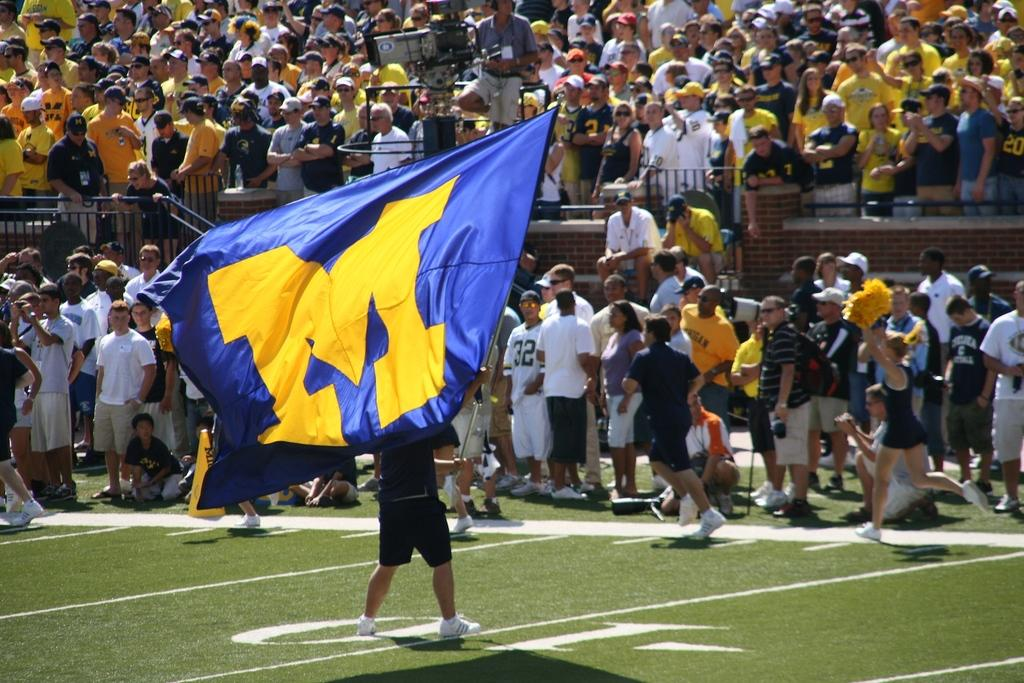Provide a one-sentence caption for the provided image. a person holding a M flag that is gold and blue. 